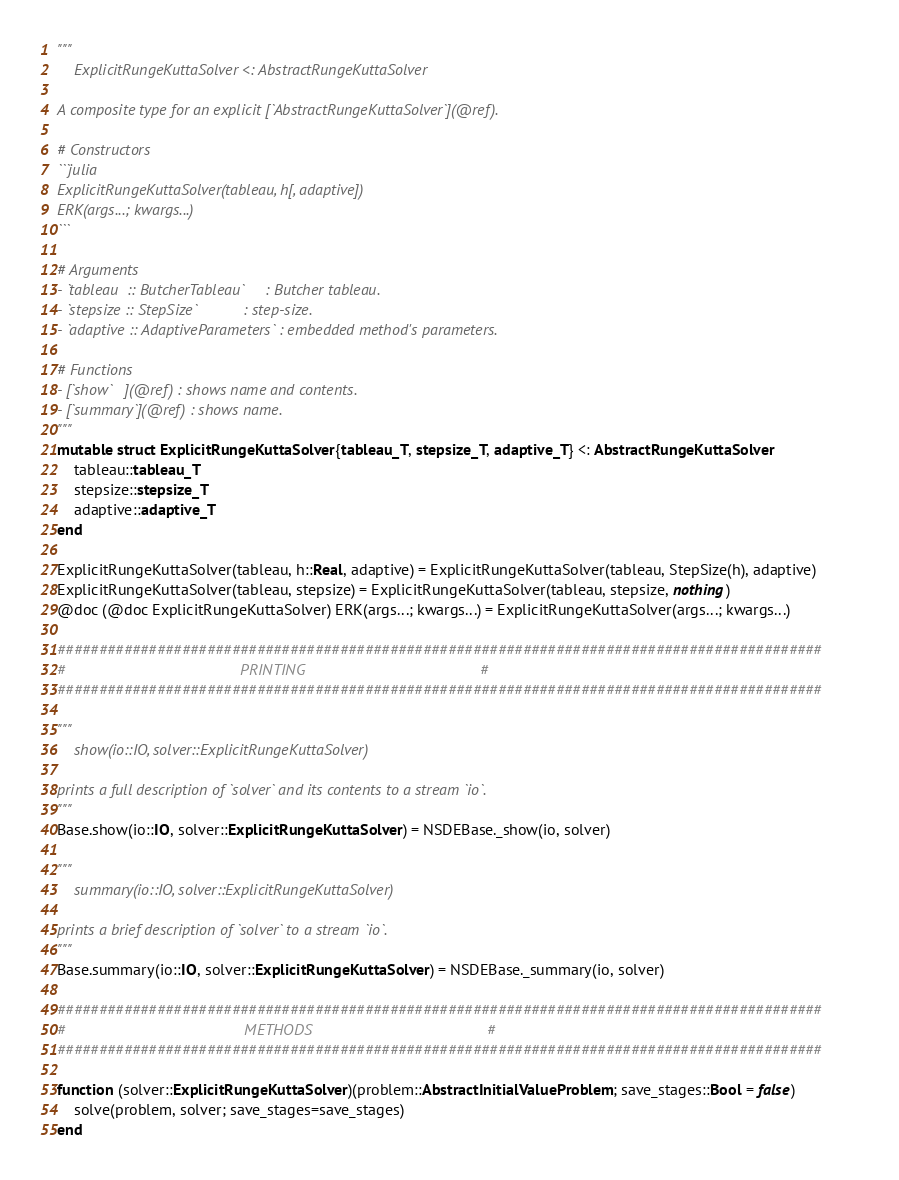Convert code to text. <code><loc_0><loc_0><loc_500><loc_500><_Julia_>"""
    ExplicitRungeKuttaSolver <: AbstractRungeKuttaSolver

A composite type for an explicit [`AbstractRungeKuttaSolver`](@ref).

# Constructors
```julia
ExplicitRungeKuttaSolver(tableau, h[, adaptive])
ERK(args...; kwargs...)
```

# Arguments
- `tableau  :: ButcherTableau`     : Butcher tableau.
- `stepsize :: StepSize`           : step-size.
- `adaptive :: AdaptiveParameters` : embedded method's parameters.

# Functions
- [`show`   ](@ref) : shows name and contents.
- [`summary`](@ref) : shows name.
"""
mutable struct ExplicitRungeKuttaSolver{tableau_T, stepsize_T, adaptive_T} <: AbstractRungeKuttaSolver
    tableau::tableau_T
    stepsize::stepsize_T
    adaptive::adaptive_T
end

ExplicitRungeKuttaSolver(tableau, h::Real, adaptive) = ExplicitRungeKuttaSolver(tableau, StepSize(h), adaptive)
ExplicitRungeKuttaSolver(tableau, stepsize) = ExplicitRungeKuttaSolver(tableau, stepsize, nothing)
@doc (@doc ExplicitRungeKuttaSolver) ERK(args...; kwargs...) = ExplicitRungeKuttaSolver(args...; kwargs...)

############################################################################################
#                                         PRINTING                                         #
############################################################################################

"""
    show(io::IO, solver::ExplicitRungeKuttaSolver)

prints a full description of `solver` and its contents to a stream `io`.
"""
Base.show(io::IO, solver::ExplicitRungeKuttaSolver) = NSDEBase._show(io, solver)

"""
    summary(io::IO, solver::ExplicitRungeKuttaSolver)

prints a brief description of `solver` to a stream `io`.
"""
Base.summary(io::IO, solver::ExplicitRungeKuttaSolver) = NSDEBase._summary(io, solver)

############################################################################################
#                                          METHODS                                         #
############################################################################################

function (solver::ExplicitRungeKuttaSolver)(problem::AbstractInitialValueProblem; save_stages::Bool = false)
    solve(problem, solver; save_stages=save_stages)
end
</code> 